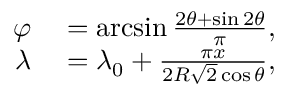<formula> <loc_0><loc_0><loc_500><loc_500>\begin{array} { r l } { \varphi } & = \arcsin { \frac { 2 \theta + \sin 2 \theta } { \pi } } , } \\ { \lambda } & = \lambda _ { 0 } + { \frac { \pi x } { 2 R { \sqrt { 2 } } \cos \theta } } , } \end{array}</formula> 